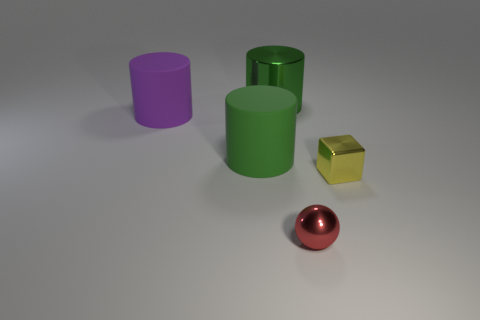There is a shiny object that is the same size as the red sphere; what shape is it?
Offer a terse response. Cube. There is a shiny object that is in front of the tiny yellow shiny object that is in front of the green thing left of the big green shiny cylinder; what is its shape?
Make the answer very short. Sphere. Are there the same number of small shiny things behind the big purple cylinder and gray objects?
Ensure brevity in your answer.  Yes. Do the red sphere and the purple matte thing have the same size?
Offer a very short reply. No. How many rubber objects are either green cylinders or small balls?
Provide a succinct answer. 1. What material is the purple cylinder that is the same size as the green rubber cylinder?
Ensure brevity in your answer.  Rubber. How many other objects are the same material as the ball?
Keep it short and to the point. 2. Is the number of red shiny things that are behind the small metal cube less than the number of shiny cubes?
Keep it short and to the point. Yes. Does the purple object have the same shape as the small yellow object?
Make the answer very short. No. What is the size of the yellow shiny object that is to the right of the green cylinder in front of the green object that is behind the big purple object?
Make the answer very short. Small. 